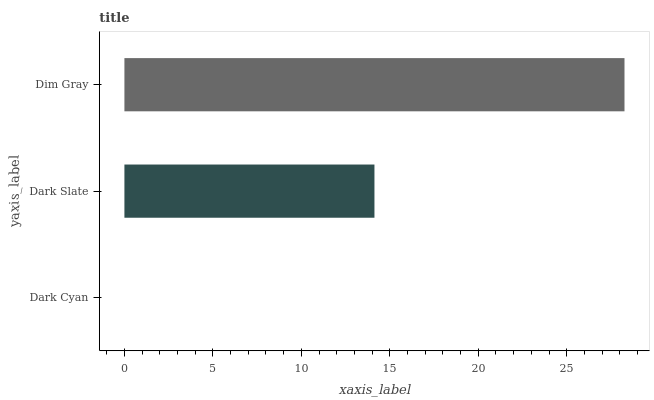Is Dark Cyan the minimum?
Answer yes or no. Yes. Is Dim Gray the maximum?
Answer yes or no. Yes. Is Dark Slate the minimum?
Answer yes or no. No. Is Dark Slate the maximum?
Answer yes or no. No. Is Dark Slate greater than Dark Cyan?
Answer yes or no. Yes. Is Dark Cyan less than Dark Slate?
Answer yes or no. Yes. Is Dark Cyan greater than Dark Slate?
Answer yes or no. No. Is Dark Slate less than Dark Cyan?
Answer yes or no. No. Is Dark Slate the high median?
Answer yes or no. Yes. Is Dark Slate the low median?
Answer yes or no. Yes. Is Dim Gray the high median?
Answer yes or no. No. Is Dim Gray the low median?
Answer yes or no. No. 